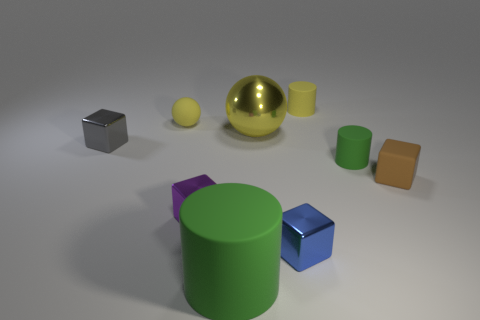Subtract all tiny brown rubber cubes. How many cubes are left? 3 Subtract all brown cubes. How many cubes are left? 3 Subtract all balls. How many objects are left? 7 Add 1 tiny gray things. How many objects exist? 10 Subtract 0 cyan balls. How many objects are left? 9 Subtract 2 balls. How many balls are left? 0 Subtract all brown cylinders. Subtract all purple cubes. How many cylinders are left? 3 Subtract all brown blocks. How many brown cylinders are left? 0 Subtract all blue cubes. Subtract all purple metallic cylinders. How many objects are left? 8 Add 4 small yellow rubber cylinders. How many small yellow rubber cylinders are left? 5 